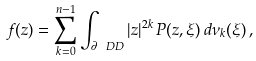<formula> <loc_0><loc_0><loc_500><loc_500>f ( z ) = \sum _ { k = 0 } ^ { n - 1 } \int _ { \partial \ D D } | z | ^ { 2 k } \, P ( z , \xi ) \, d \nu _ { k } ( \xi ) \, ,</formula> 